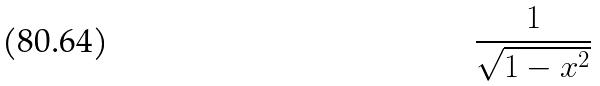<formula> <loc_0><loc_0><loc_500><loc_500>\frac { 1 } { \sqrt { 1 - x ^ { 2 } } }</formula> 